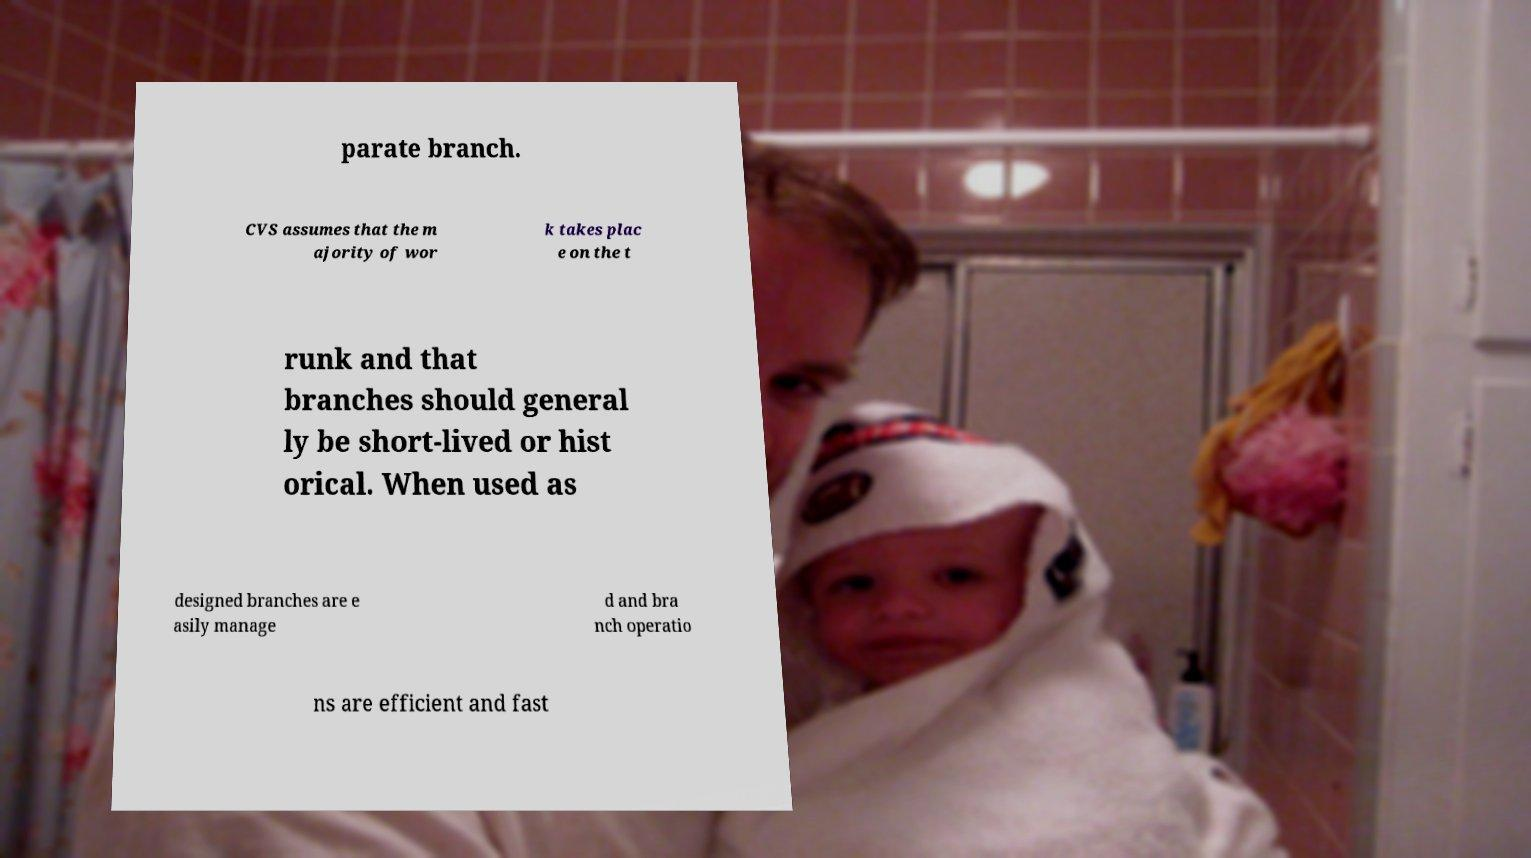Could you extract and type out the text from this image? parate branch. CVS assumes that the m ajority of wor k takes plac e on the t runk and that branches should general ly be short-lived or hist orical. When used as designed branches are e asily manage d and bra nch operatio ns are efficient and fast 